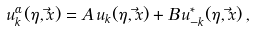Convert formula to latex. <formula><loc_0><loc_0><loc_500><loc_500>u _ { k } ^ { \alpha } ( \eta , \vec { x } ) = A \, u _ { k } ( \eta , \vec { x } ) + B \, u _ { - k } ^ { * } ( \eta , \vec { x } ) \, ,</formula> 